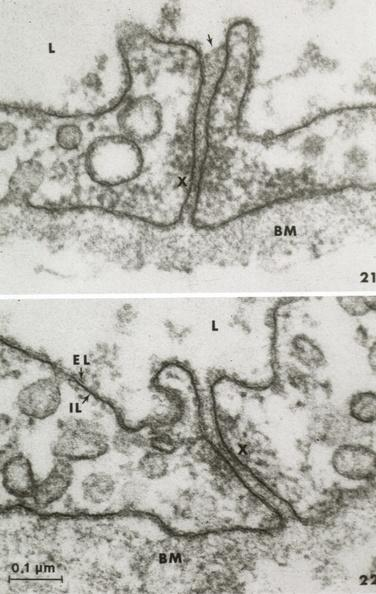s cardiovascular present?
Answer the question using a single word or phrase. Yes 